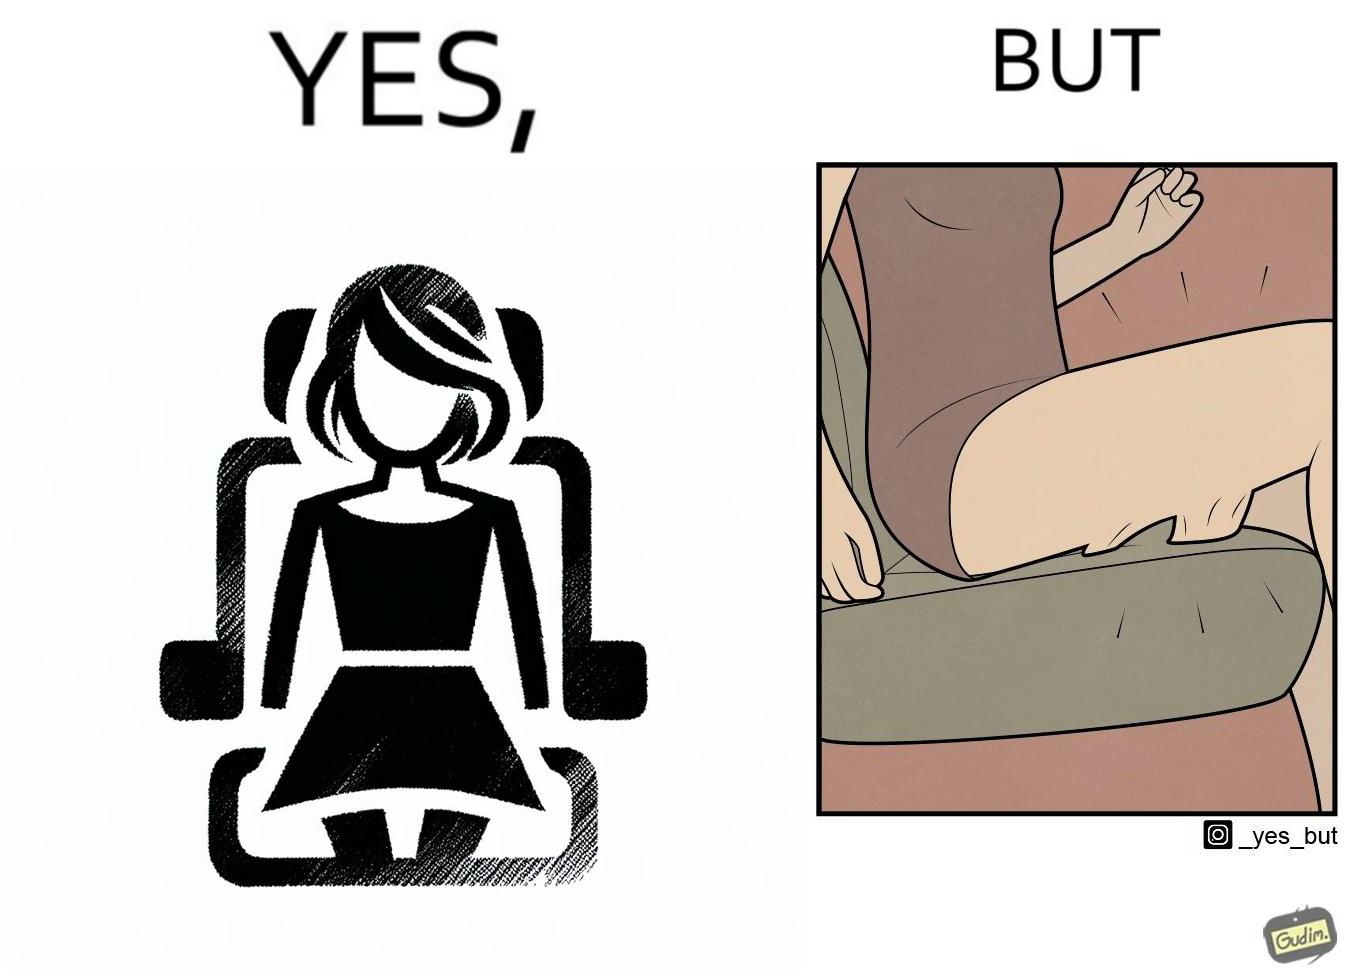Why is this image considered satirical? The image is ironic, because the woman is wearing a short dress to look stylish but she had to face inconvenience while travelling in car due to her short dress only. 